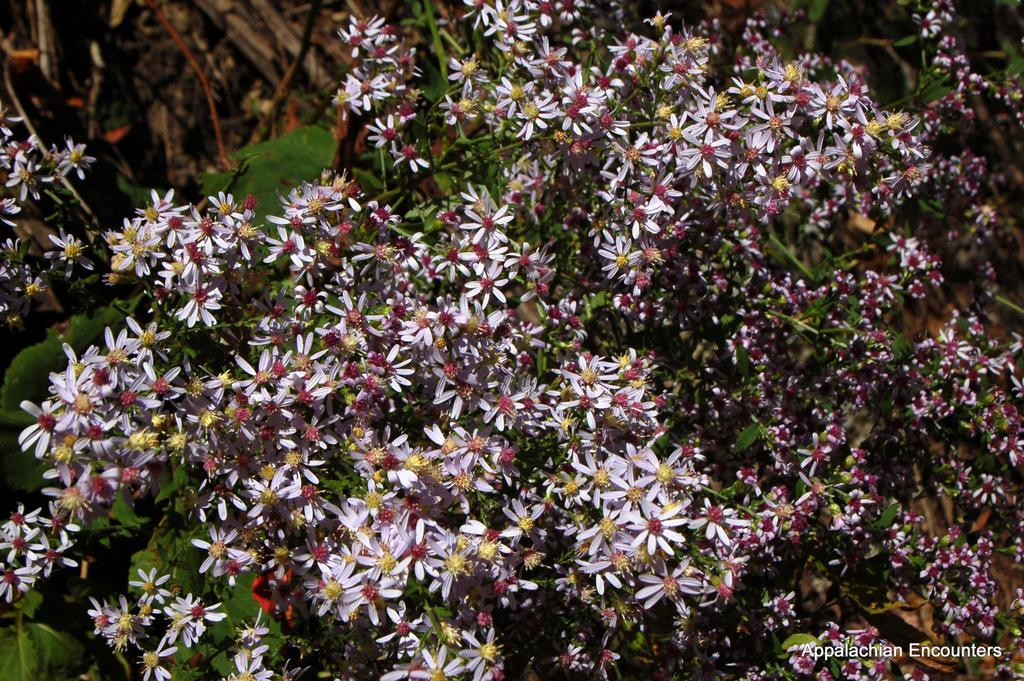What is the main subject of the image? The main subject of the image is flowers. Can you describe the flowers in the image? The flowers are located in the center of the image. What type of birds can be seen in the image? There are no birds present in the image; it features flowers in the center. Is there a zoo visible in the image? There is no zoo present in the image; it features flowers in the center. 